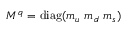Convert formula to latex. <formula><loc_0><loc_0><loc_500><loc_500>M ^ { q } = { d i a g } ( m _ { u } \ m _ { d } \ m _ { s } )</formula> 